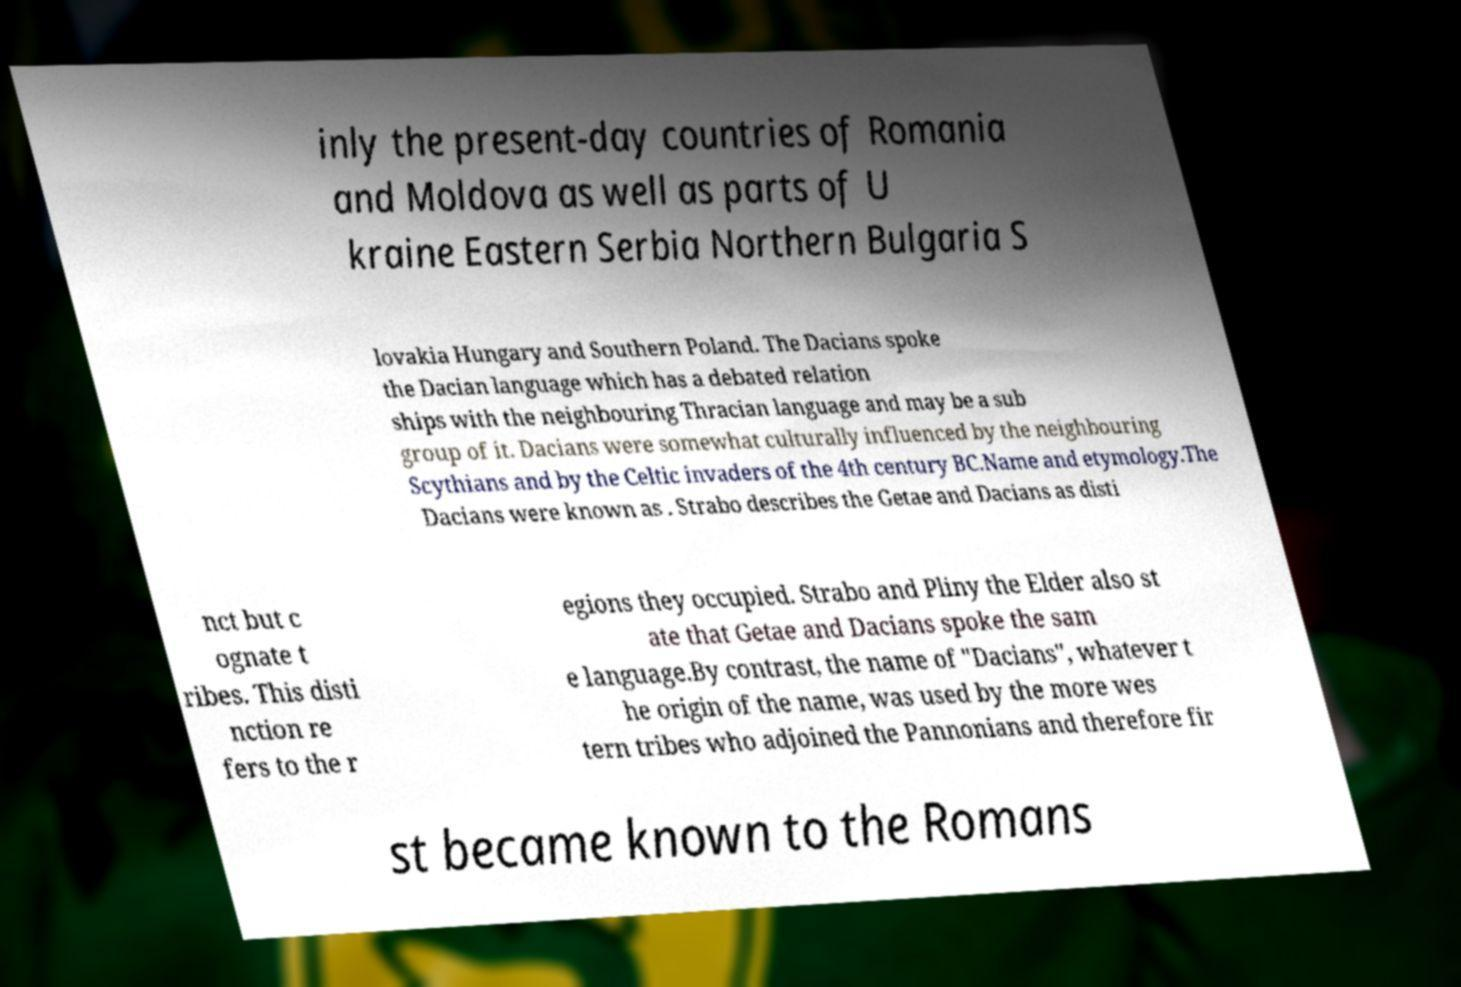Please read and relay the text visible in this image. What does it say? inly the present-day countries of Romania and Moldova as well as parts of U kraine Eastern Serbia Northern Bulgaria S lovakia Hungary and Southern Poland. The Dacians spoke the Dacian language which has a debated relation ships with the neighbouring Thracian language and may be a sub group of it. Dacians were somewhat culturally influenced by the neighbouring Scythians and by the Celtic invaders of the 4th century BC.Name and etymology.The Dacians were known as . Strabo describes the Getae and Dacians as disti nct but c ognate t ribes. This disti nction re fers to the r egions they occupied. Strabo and Pliny the Elder also st ate that Getae and Dacians spoke the sam e language.By contrast, the name of "Dacians", whatever t he origin of the name, was used by the more wes tern tribes who adjoined the Pannonians and therefore fir st became known to the Romans 